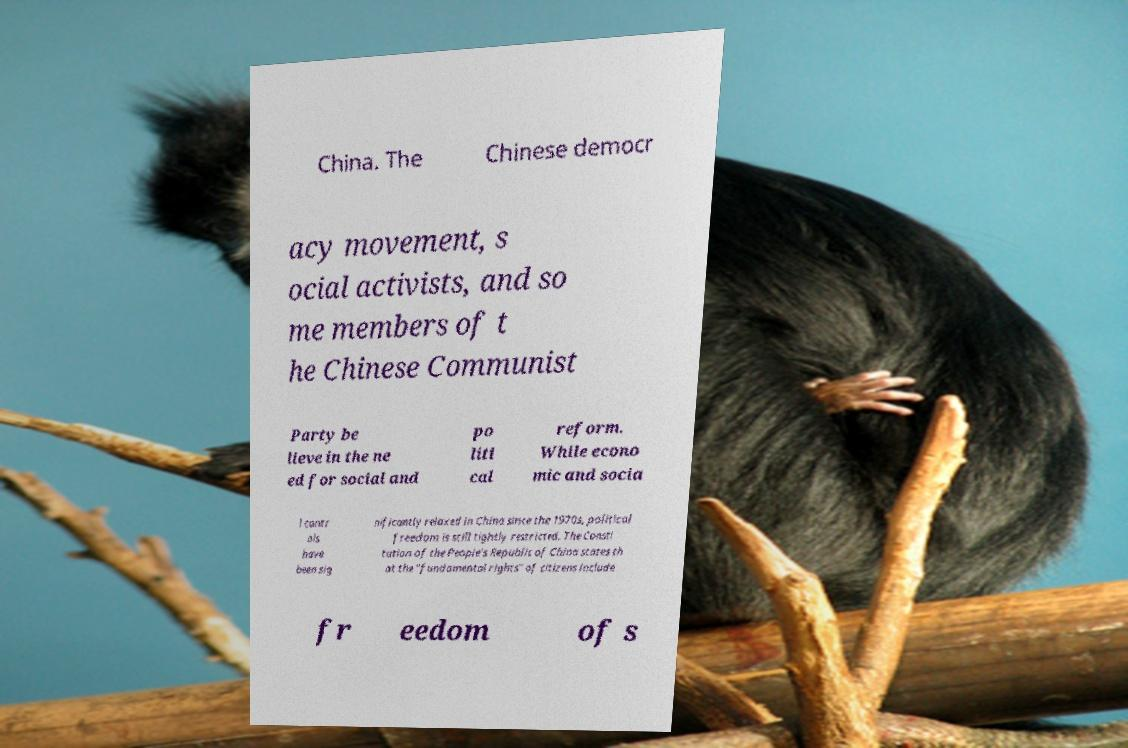Could you assist in decoding the text presented in this image and type it out clearly? China. The Chinese democr acy movement, s ocial activists, and so me members of t he Chinese Communist Party be lieve in the ne ed for social and po liti cal reform. While econo mic and socia l contr ols have been sig nificantly relaxed in China since the 1970s, political freedom is still tightly restricted. The Consti tution of the People's Republic of China states th at the "fundamental rights" of citizens include fr eedom of s 